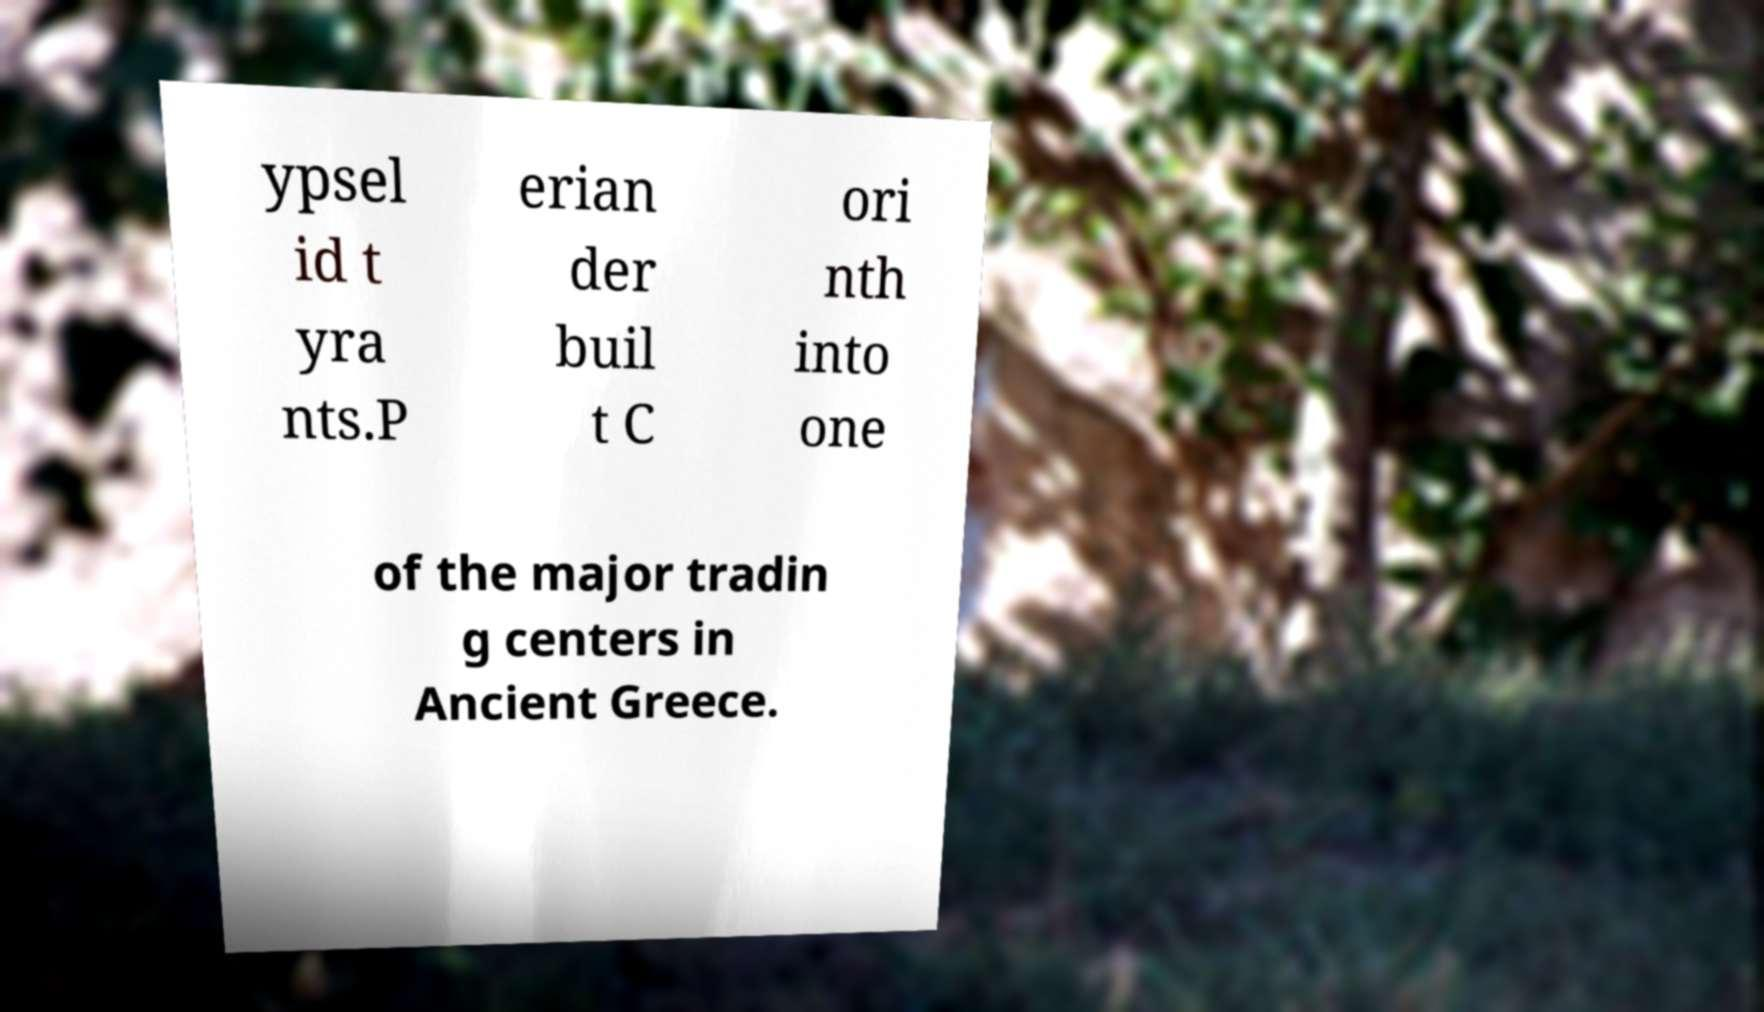Could you assist in decoding the text presented in this image and type it out clearly? ypsel id t yra nts.P erian der buil t C ori nth into one of the major tradin g centers in Ancient Greece. 